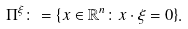Convert formula to latex. <formula><loc_0><loc_0><loc_500><loc_500>\Pi ^ { \xi } \colon = \{ x \in \mathbb { R } ^ { n } \colon x \cdot \xi = 0 \} .</formula> 